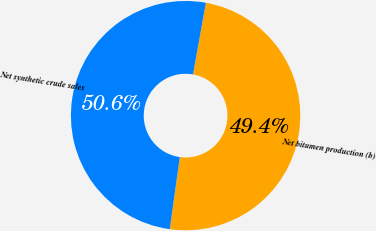Convert chart to OTSL. <chart><loc_0><loc_0><loc_500><loc_500><pie_chart><fcel>Net bitumen production (b)<fcel>Net synthetic crude sales<nl><fcel>49.38%<fcel>50.62%<nl></chart> 